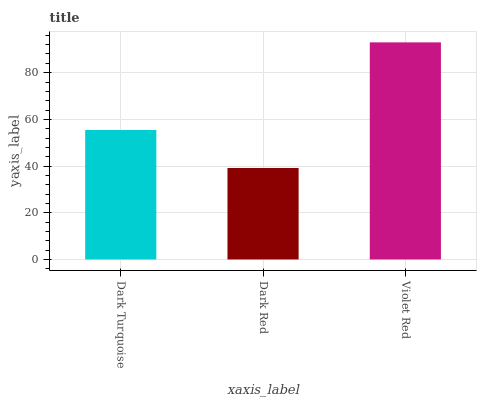Is Dark Red the minimum?
Answer yes or no. Yes. Is Violet Red the maximum?
Answer yes or no. Yes. Is Violet Red the minimum?
Answer yes or no. No. Is Dark Red the maximum?
Answer yes or no. No. Is Violet Red greater than Dark Red?
Answer yes or no. Yes. Is Dark Red less than Violet Red?
Answer yes or no. Yes. Is Dark Red greater than Violet Red?
Answer yes or no. No. Is Violet Red less than Dark Red?
Answer yes or no. No. Is Dark Turquoise the high median?
Answer yes or no. Yes. Is Dark Turquoise the low median?
Answer yes or no. Yes. Is Dark Red the high median?
Answer yes or no. No. Is Violet Red the low median?
Answer yes or no. No. 